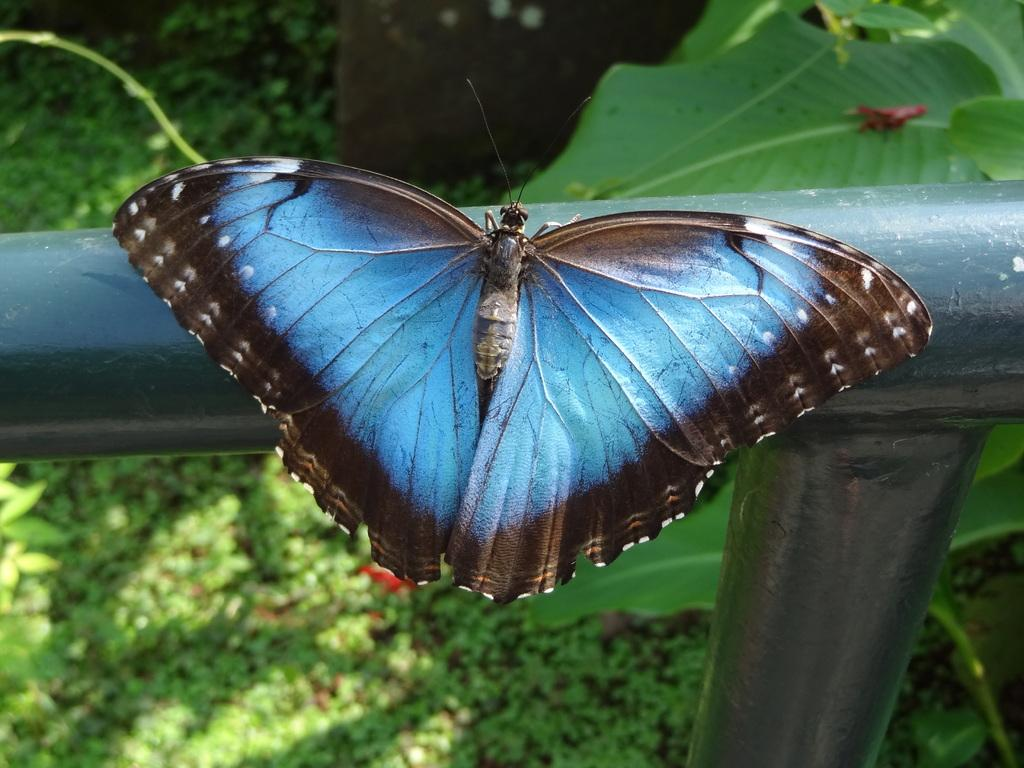What is on the metal fence in the image? There is a butterfly on the metal fence in the image. What is behind the metal fence? There is a plant behind the metal fence. What can be seen in the background of the image? There are plants on the land in the background of the image. What type of bomb is being diffused in the image? There is no bomb present in the image; it features a butterfly on a metal fence and plants in the background. What type of skin condition is visible on the butterfly in the image? There is no indication of any skin condition on the butterfly in the image, as it is a photograph of a butterfly on a metal fence and plants. 